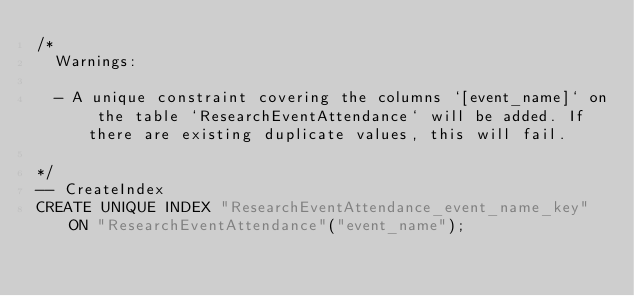Convert code to text. <code><loc_0><loc_0><loc_500><loc_500><_SQL_>/*
  Warnings:

  - A unique constraint covering the columns `[event_name]` on the table `ResearchEventAttendance` will be added. If there are existing duplicate values, this will fail.

*/
-- CreateIndex
CREATE UNIQUE INDEX "ResearchEventAttendance_event_name_key" ON "ResearchEventAttendance"("event_name");
</code> 